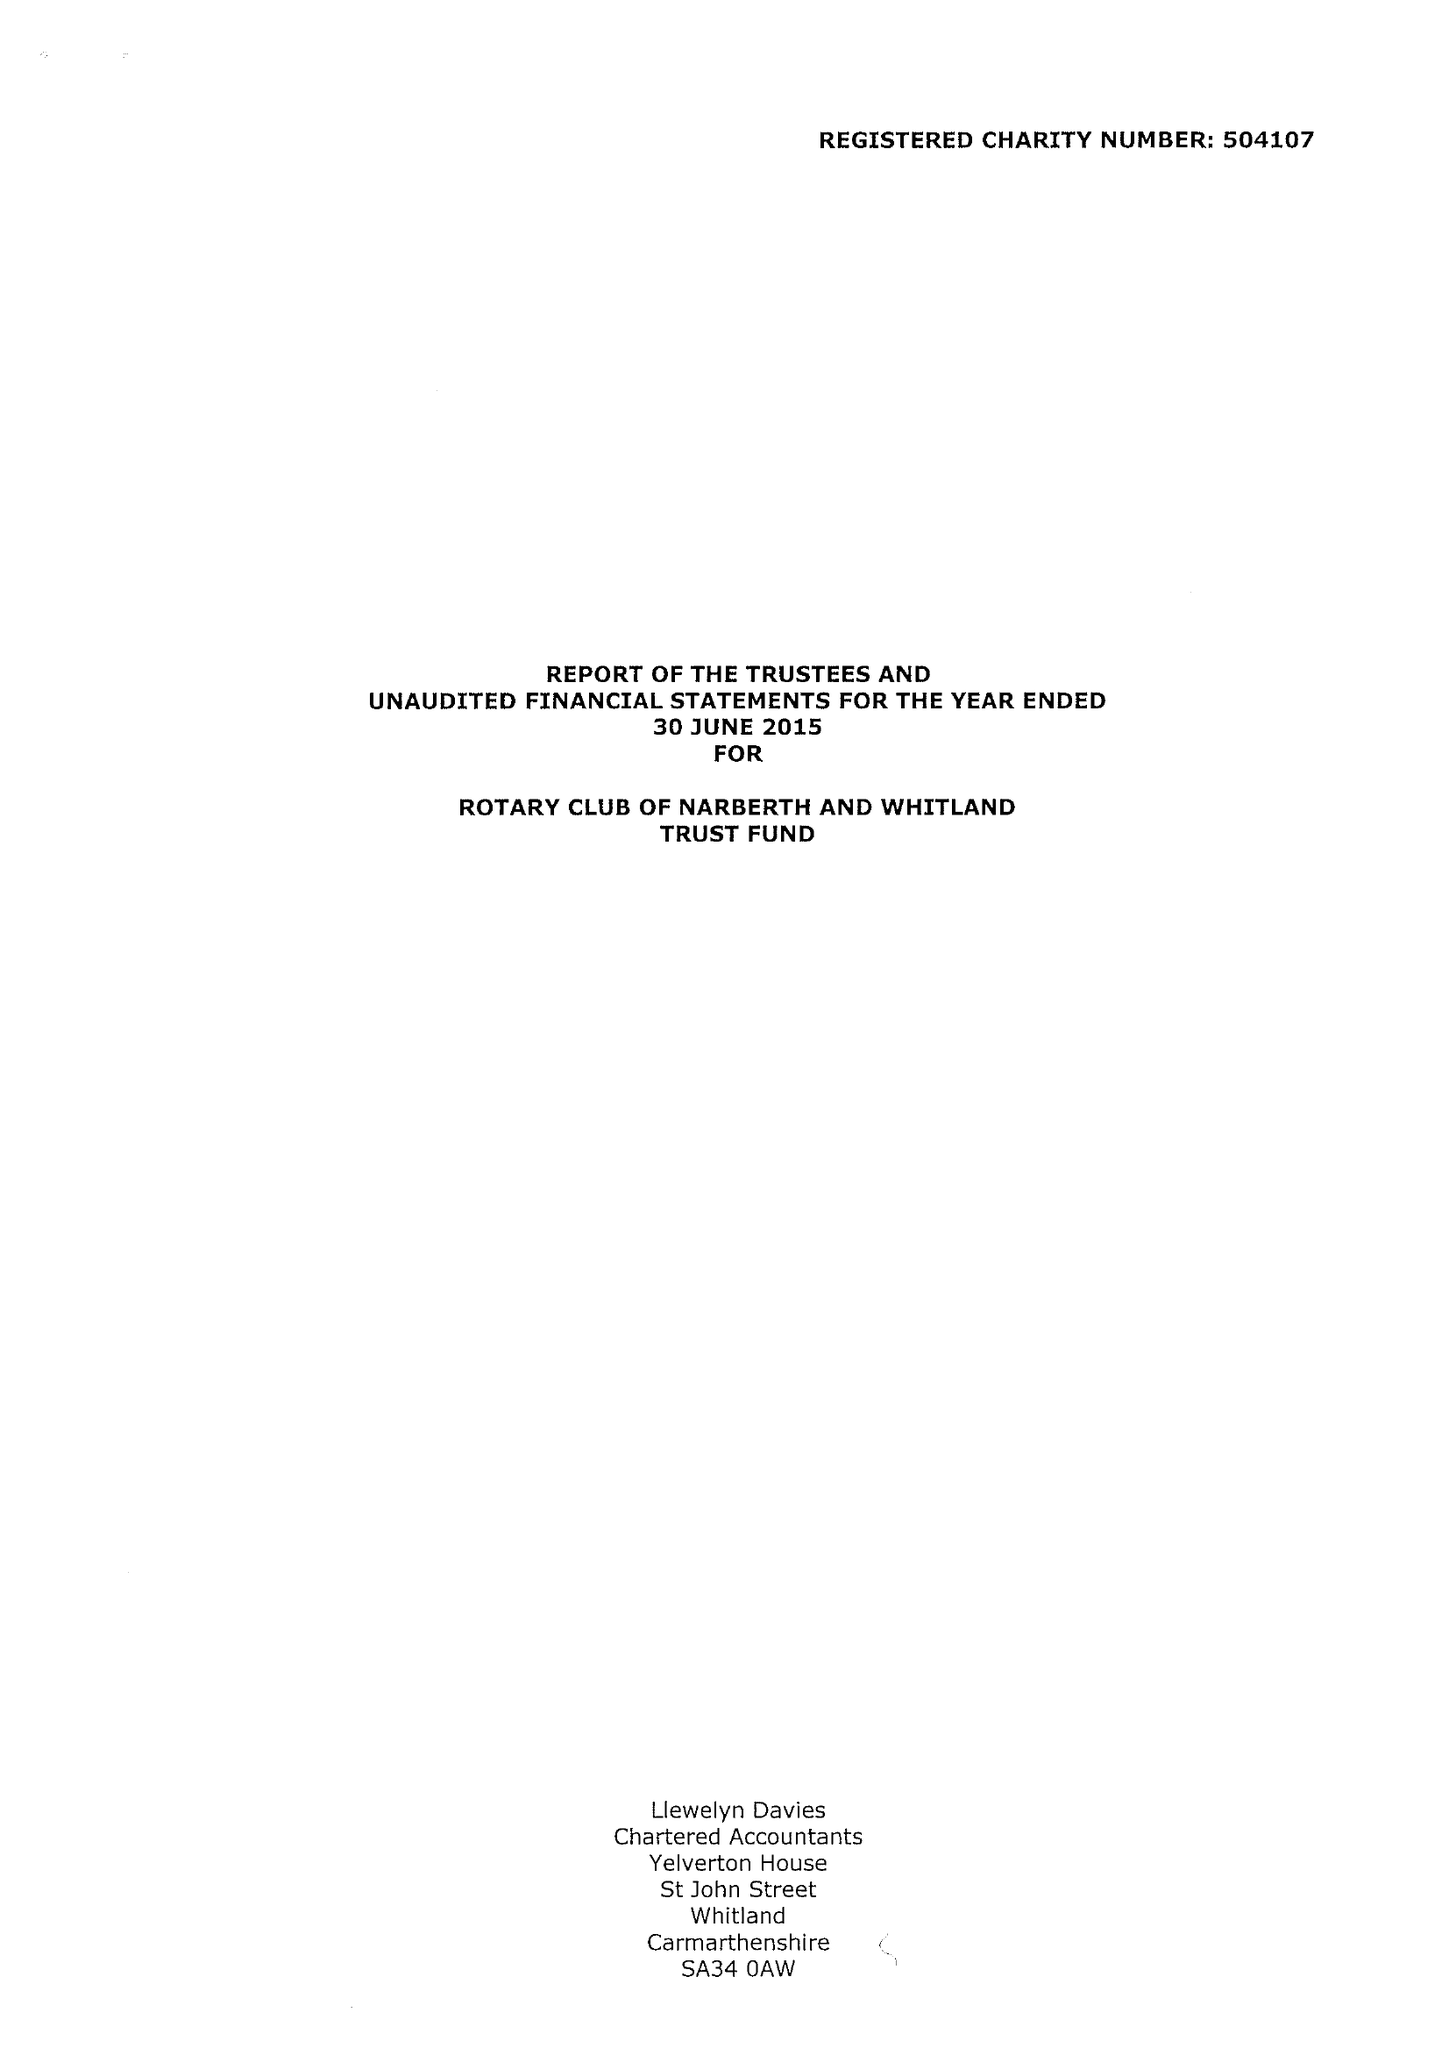What is the value for the report_date?
Answer the question using a single word or phrase. 2015-06-30 